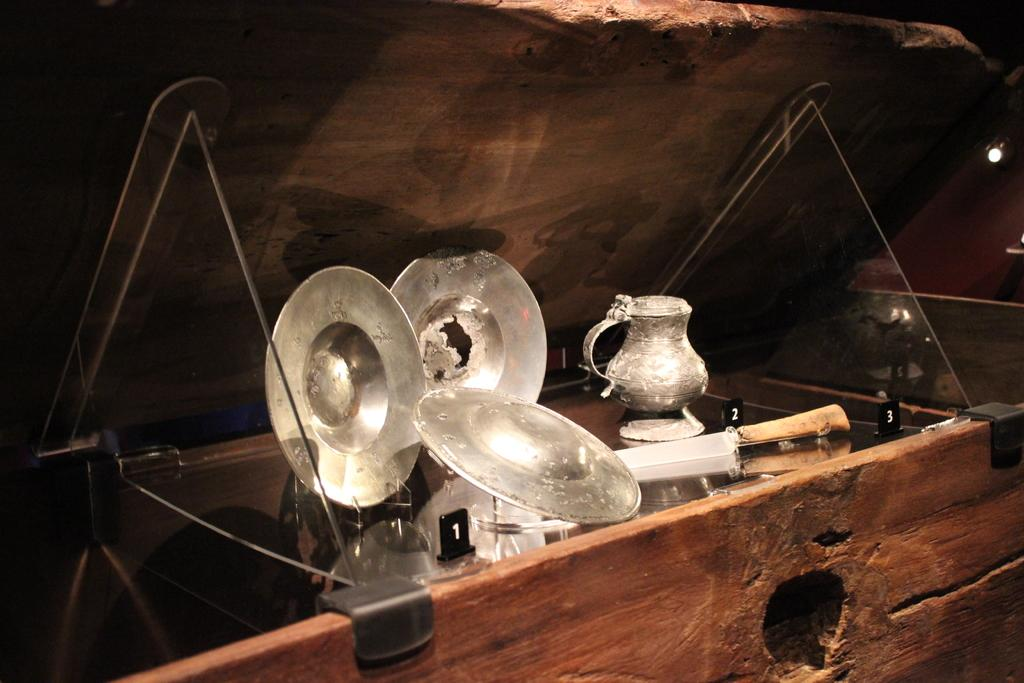What is the main object in the image? There is a box in the image. What items are inside the box? The box contains plates, a jar, and other objects. Can you describe the light in the image? There is a light on the right side of the image. How many houses can be seen in the image? There are no houses visible in the image; it features a box with various items inside. Is there a snail crawling on the jar in the image? There is no snail present in the image. 